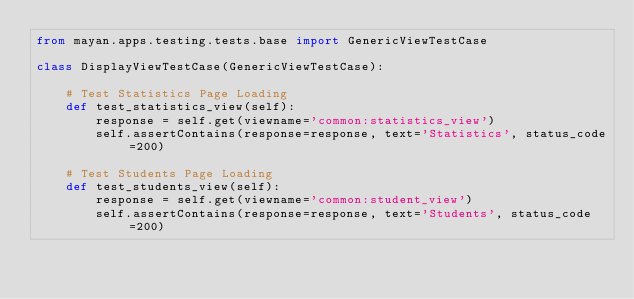<code> <loc_0><loc_0><loc_500><loc_500><_Python_>from mayan.apps.testing.tests.base import GenericViewTestCase

class DisplayViewTestCase(GenericViewTestCase):

	# Test Statistics Page Loading
    def test_statistics_view(self):
        response = self.get(viewname='common:statistics_view')
        self.assertContains(response=response, text='Statistics', status_code=200)

    # Test Students Page Loading 
    def test_students_view(self):
        response = self.get(viewname='common:student_view')
        self.assertContains(response=response, text='Students', status_code=200)</code> 